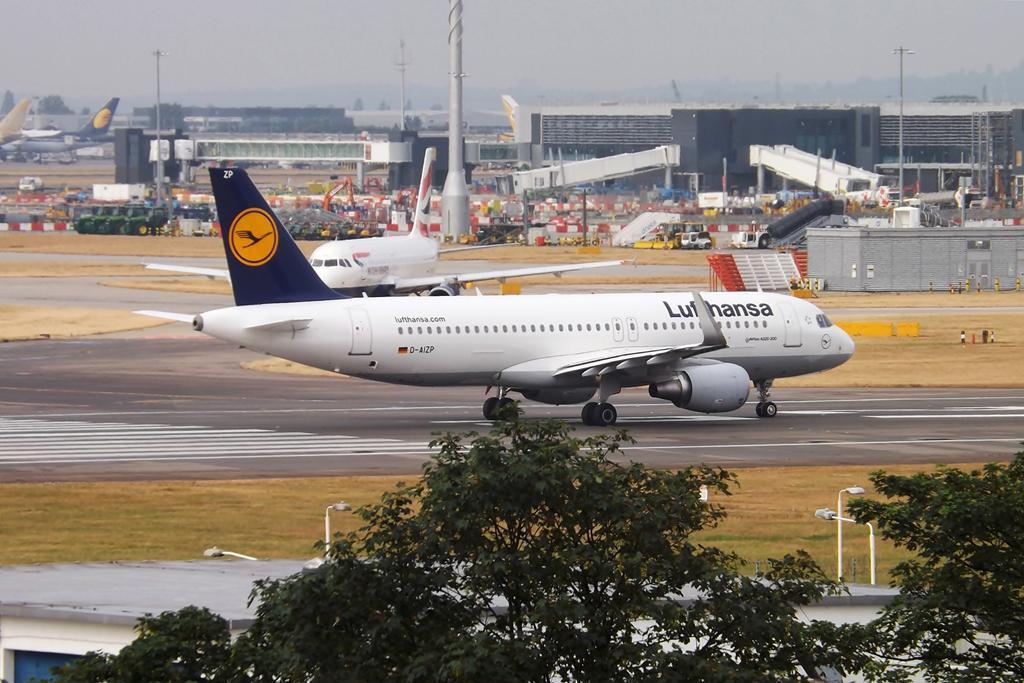In one or two sentences, can you explain what this image depicts? In this image we can see the airplanes on the runway. We can also see some poles, fence, barriers, some vehicles on the ground, buildings, a group of trees and the sky which looks cloudy. 